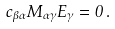Convert formula to latex. <formula><loc_0><loc_0><loc_500><loc_500>c _ { \beta \alpha } M _ { \alpha \gamma } E _ { \gamma } = 0 \, .</formula> 